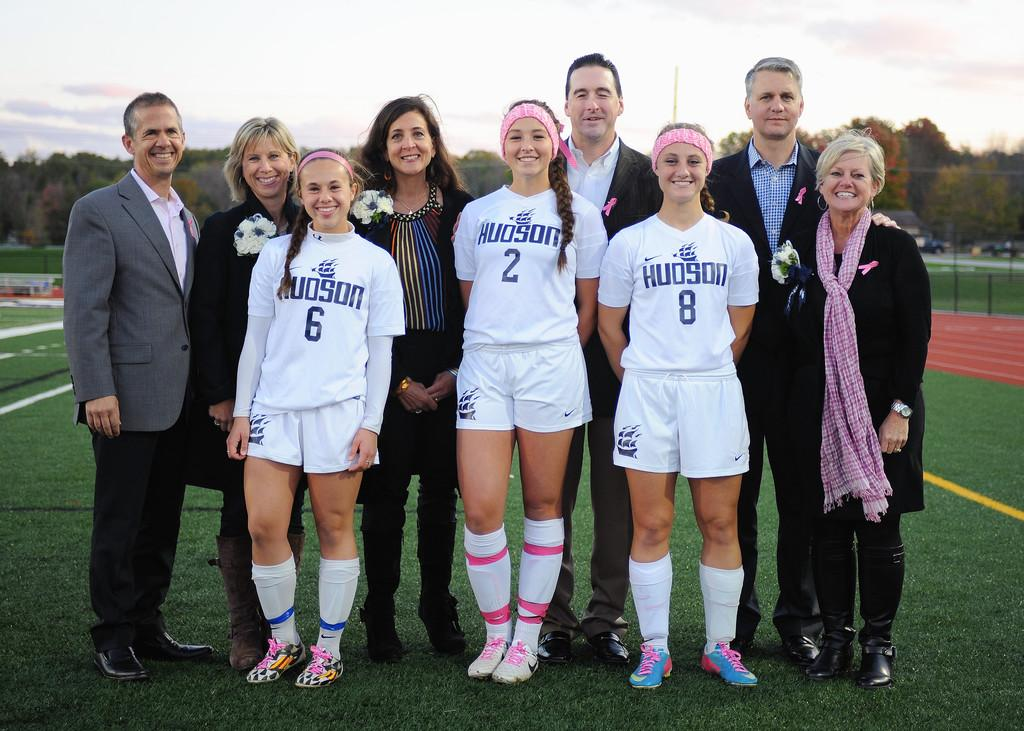<image>
Provide a brief description of the given image. A group of people are standing in an athletic field and wearing uniforms that say Hudson. 